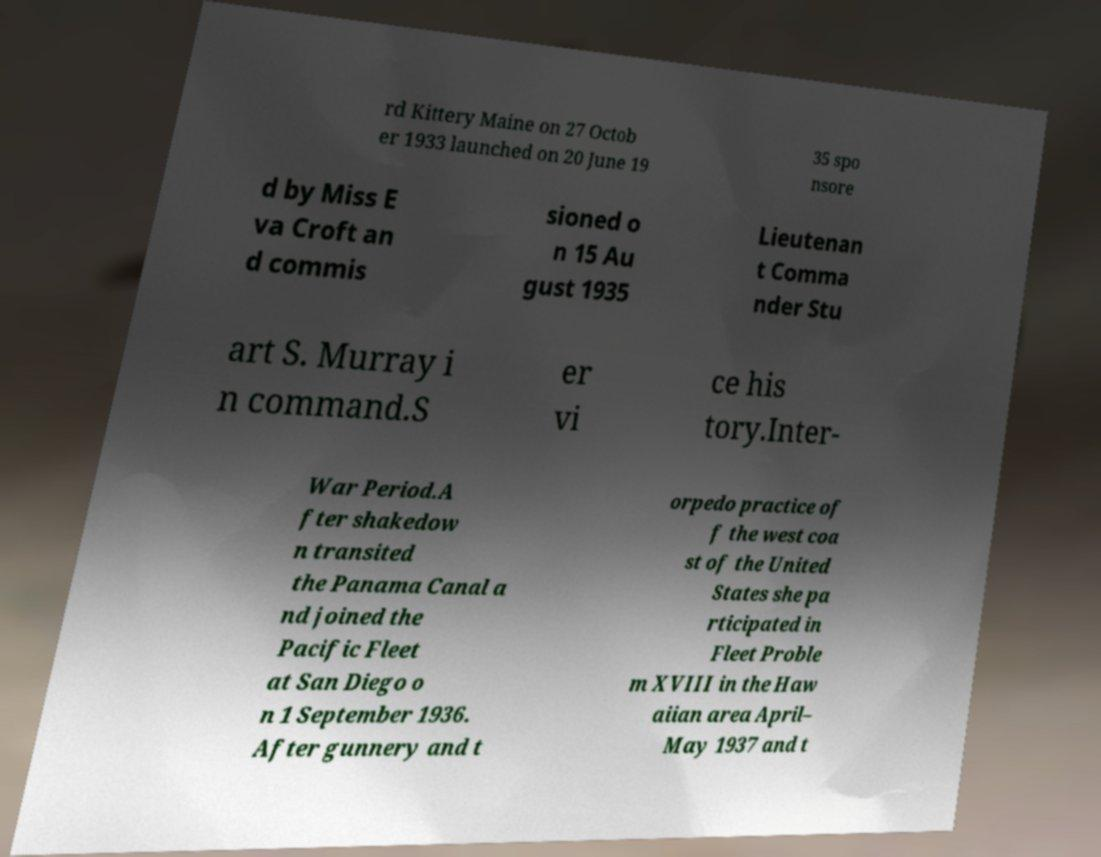For documentation purposes, I need the text within this image transcribed. Could you provide that? rd Kittery Maine on 27 Octob er 1933 launched on 20 June 19 35 spo nsore d by Miss E va Croft an d commis sioned o n 15 Au gust 1935 Lieutenan t Comma nder Stu art S. Murray i n command.S er vi ce his tory.Inter- War Period.A fter shakedow n transited the Panama Canal a nd joined the Pacific Fleet at San Diego o n 1 September 1936. After gunnery and t orpedo practice of f the west coa st of the United States she pa rticipated in Fleet Proble m XVIII in the Haw aiian area April– May 1937 and t 